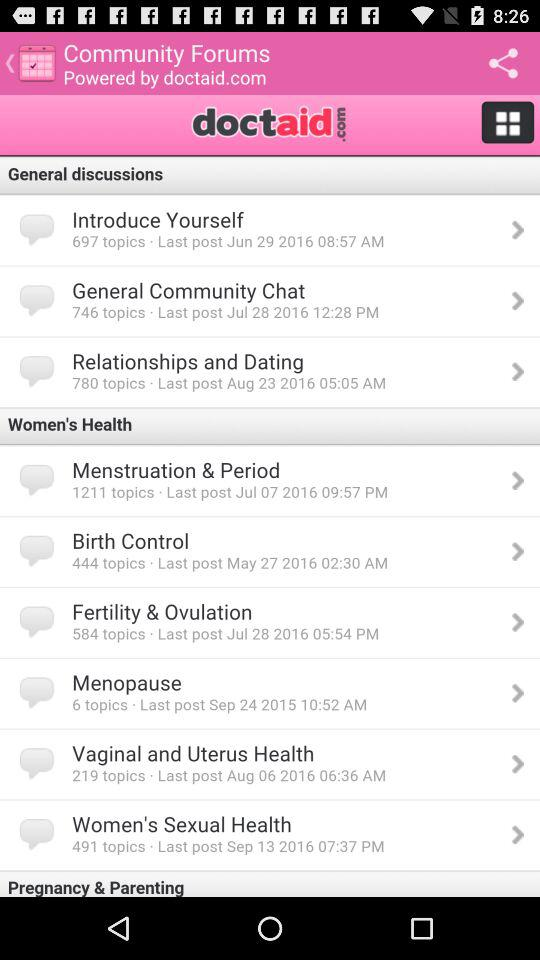When was the last topic in "Menopause" posted? The last topic in "Menopause" was posted on September 24, 2015 at 10:52 a.m. 